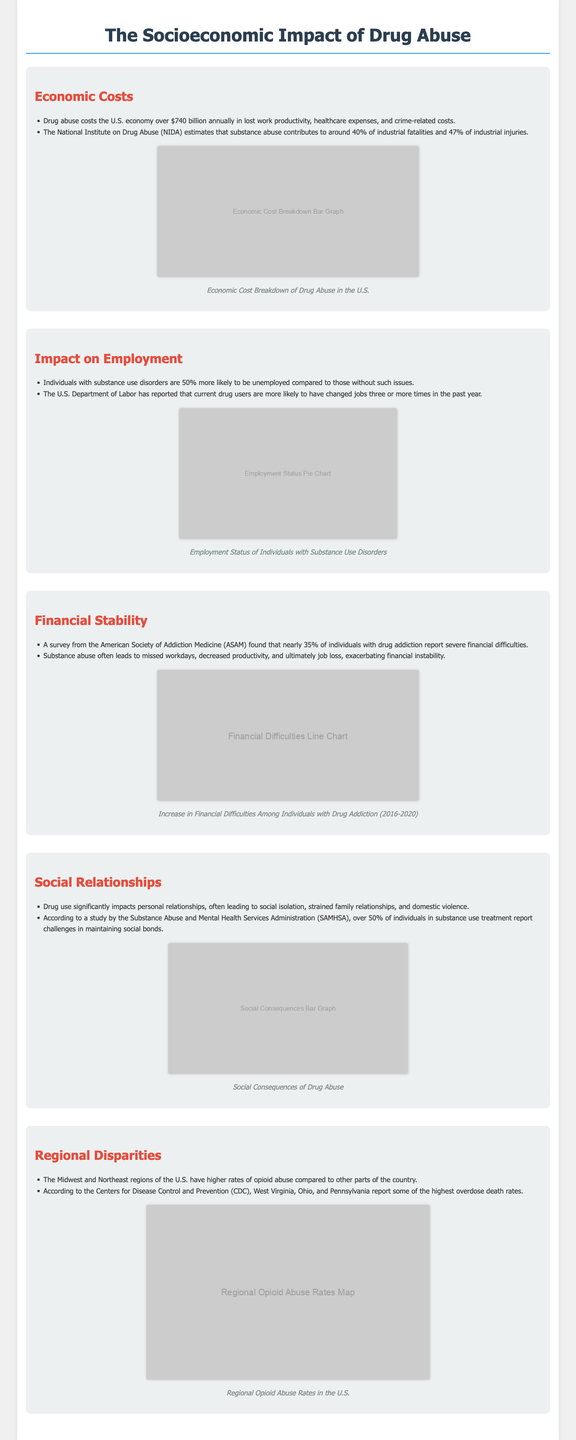What is the annual cost of drug abuse to the U.S. economy? The document states that drug abuse costs the U.S. economy over $740 billion annually in lost work productivity, healthcare expenses, and crime-related costs.
Answer: $740 billion What percentage of industrial fatalities is attributed to substance abuse? According to the document, substance abuse contributes to around 40% of industrial fatalities.
Answer: 40% What is the unemployment likelihood for individuals with substance use disorders compared to others? The document states that individuals with substance use disorders are 50% more likely to be unemployed compared to those without such issues.
Answer: 50% What percentage of individuals in substance use treatment report challenges in maintaining social bonds? The document mentions that over 50% of individuals in substance use treatment report challenges in maintaining social bonds.
Answer: 50% Which region in the U.S. has higher rates of opioid abuse? The document indicates that the Midwest and Northeast regions of the U.S. have higher rates of opioid abuse.
Answer: Midwest and Northeast What does the pie chart in the Impact on Employment section illustrate? The pie chart illustrates the employment status of individuals with substance use disorders.
Answer: Employment status How many percent of individuals with drug addiction report severe financial difficulties? A survey found that nearly 35% of individuals with drug addiction report severe financial difficulties.
Answer: 35% Which states report some of the highest overdose death rates? The document identifies West Virginia, Ohio, and Pennsylvania as states with some of the highest overdose death rates.
Answer: West Virginia, Ohio, Pennsylvania What type of economic costs are discussed in the infographic? The infographic discusses lost work productivity, healthcare expenses, and crime-related costs due to drug abuse.
Answer: Lost work productivity, healthcare expenses, crime-related costs 